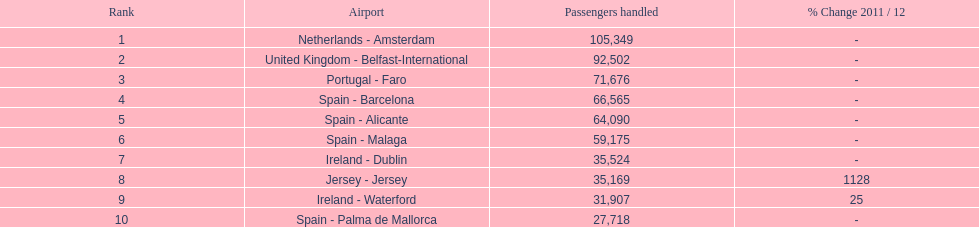Which airport has no more than 30,000 passengers handled among the 10 busiest routes to and from london southend airport in 2012? Spain - Palma de Mallorca. 